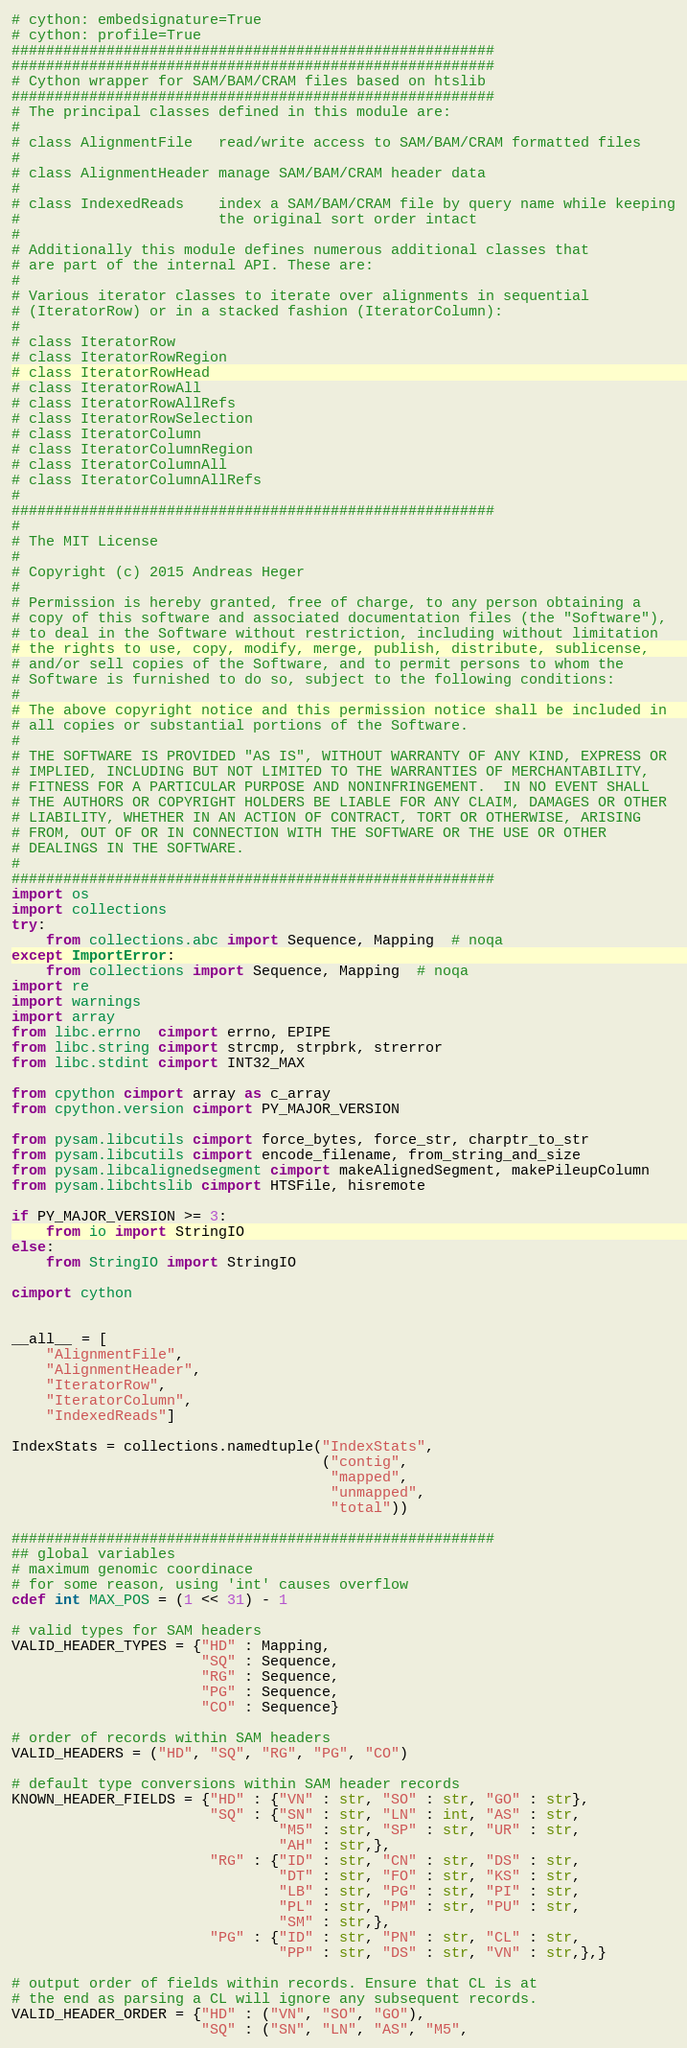Convert code to text. <code><loc_0><loc_0><loc_500><loc_500><_Cython_># cython: embedsignature=True
# cython: profile=True
########################################################
########################################################
# Cython wrapper for SAM/BAM/CRAM files based on htslib
########################################################
# The principal classes defined in this module are:
#
# class AlignmentFile   read/write access to SAM/BAM/CRAM formatted files
#
# class AlignmentHeader manage SAM/BAM/CRAM header data
#
# class IndexedReads    index a SAM/BAM/CRAM file by query name while keeping
#                       the original sort order intact
#
# Additionally this module defines numerous additional classes that
# are part of the internal API. These are:
#
# Various iterator classes to iterate over alignments in sequential
# (IteratorRow) or in a stacked fashion (IteratorColumn):
#
# class IteratorRow
# class IteratorRowRegion
# class IteratorRowHead
# class IteratorRowAll
# class IteratorRowAllRefs
# class IteratorRowSelection
# class IteratorColumn
# class IteratorColumnRegion
# class IteratorColumnAll
# class IteratorColumnAllRefs
#
########################################################
#
# The MIT License
#
# Copyright (c) 2015 Andreas Heger
#
# Permission is hereby granted, free of charge, to any person obtaining a
# copy of this software and associated documentation files (the "Software"),
# to deal in the Software without restriction, including without limitation
# the rights to use, copy, modify, merge, publish, distribute, sublicense,
# and/or sell copies of the Software, and to permit persons to whom the
# Software is furnished to do so, subject to the following conditions:
#
# The above copyright notice and this permission notice shall be included in
# all copies or substantial portions of the Software.
#
# THE SOFTWARE IS PROVIDED "AS IS", WITHOUT WARRANTY OF ANY KIND, EXPRESS OR
# IMPLIED, INCLUDING BUT NOT LIMITED TO THE WARRANTIES OF MERCHANTABILITY,
# FITNESS FOR A PARTICULAR PURPOSE AND NONINFRINGEMENT.  IN NO EVENT SHALL
# THE AUTHORS OR COPYRIGHT HOLDERS BE LIABLE FOR ANY CLAIM, DAMAGES OR OTHER
# LIABILITY, WHETHER IN AN ACTION OF CONTRACT, TORT OR OTHERWISE, ARISING
# FROM, OUT OF OR IN CONNECTION WITH THE SOFTWARE OR THE USE OR OTHER
# DEALINGS IN THE SOFTWARE.
#
########################################################
import os
import collections
try:
    from collections.abc import Sequence, Mapping  # noqa
except ImportError:
    from collections import Sequence, Mapping  # noqa
import re
import warnings
import array
from libc.errno  cimport errno, EPIPE
from libc.string cimport strcmp, strpbrk, strerror
from libc.stdint cimport INT32_MAX

from cpython cimport array as c_array
from cpython.version cimport PY_MAJOR_VERSION

from pysam.libcutils cimport force_bytes, force_str, charptr_to_str
from pysam.libcutils cimport encode_filename, from_string_and_size
from pysam.libcalignedsegment cimport makeAlignedSegment, makePileupColumn
from pysam.libchtslib cimport HTSFile, hisremote

if PY_MAJOR_VERSION >= 3:
    from io import StringIO
else:
    from StringIO import StringIO

cimport cython


__all__ = [
    "AlignmentFile",
    "AlignmentHeader",
    "IteratorRow",
    "IteratorColumn",
    "IndexedReads"]

IndexStats = collections.namedtuple("IndexStats",
                                    ("contig",
                                     "mapped",
                                     "unmapped",
                                     "total"))

########################################################
## global variables
# maximum genomic coordinace
# for some reason, using 'int' causes overflow
cdef int MAX_POS = (1 << 31) - 1

# valid types for SAM headers
VALID_HEADER_TYPES = {"HD" : Mapping,
                      "SQ" : Sequence,
                      "RG" : Sequence,
                      "PG" : Sequence,
                      "CO" : Sequence}

# order of records within SAM headers
VALID_HEADERS = ("HD", "SQ", "RG", "PG", "CO")

# default type conversions within SAM header records
KNOWN_HEADER_FIELDS = {"HD" : {"VN" : str, "SO" : str, "GO" : str},
                       "SQ" : {"SN" : str, "LN" : int, "AS" : str,
                               "M5" : str, "SP" : str, "UR" : str,
                               "AH" : str,},
                       "RG" : {"ID" : str, "CN" : str, "DS" : str,
                               "DT" : str, "FO" : str, "KS" : str,
                               "LB" : str, "PG" : str, "PI" : str,
                               "PL" : str, "PM" : str, "PU" : str,
                               "SM" : str,},
                       "PG" : {"ID" : str, "PN" : str, "CL" : str,
                               "PP" : str, "DS" : str, "VN" : str,},}

# output order of fields within records. Ensure that CL is at
# the end as parsing a CL will ignore any subsequent records.
VALID_HEADER_ORDER = {"HD" : ("VN", "SO", "GO"),
                      "SQ" : ("SN", "LN", "AS", "M5",</code> 